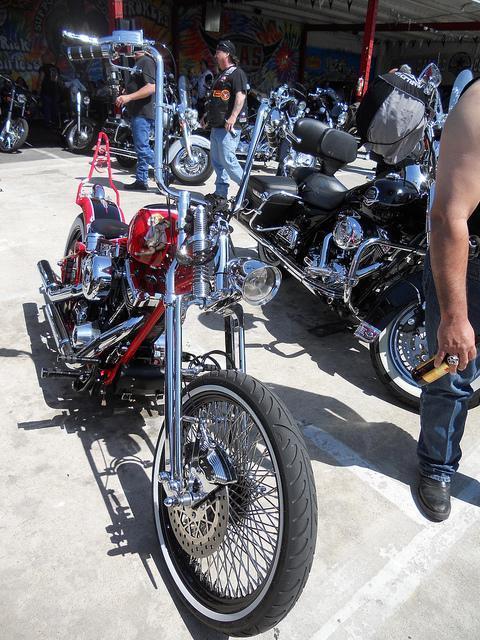How many motorcycles are in the picture?
Give a very brief answer. 4. How many people are there?
Give a very brief answer. 3. How many horses have a rider on them?
Give a very brief answer. 0. 